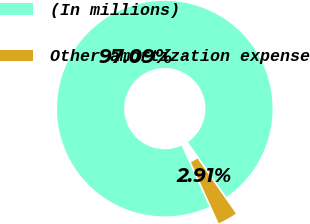<chart> <loc_0><loc_0><loc_500><loc_500><pie_chart><fcel>(In millions)<fcel>Other amortization expense<nl><fcel>97.09%<fcel>2.91%<nl></chart> 